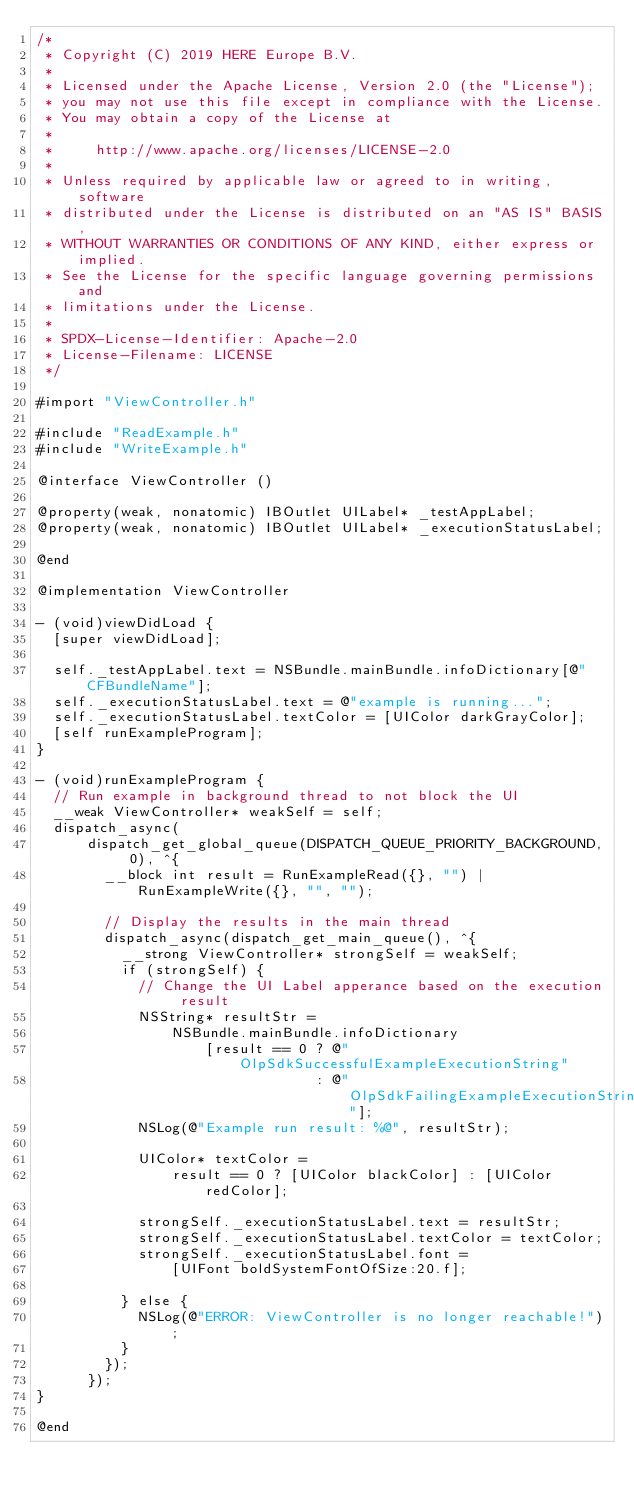Convert code to text. <code><loc_0><loc_0><loc_500><loc_500><_ObjectiveC_>/*
 * Copyright (C) 2019 HERE Europe B.V.
 *
 * Licensed under the Apache License, Version 2.0 (the "License");
 * you may not use this file except in compliance with the License.
 * You may obtain a copy of the License at
 *
 *     http://www.apache.org/licenses/LICENSE-2.0
 *
 * Unless required by applicable law or agreed to in writing, software
 * distributed under the License is distributed on an "AS IS" BASIS,
 * WITHOUT WARRANTIES OR CONDITIONS OF ANY KIND, either express or implied.
 * See the License for the specific language governing permissions and
 * limitations under the License.
 *
 * SPDX-License-Identifier: Apache-2.0
 * License-Filename: LICENSE
 */

#import "ViewController.h"

#include "ReadExample.h"
#include "WriteExample.h"

@interface ViewController ()

@property(weak, nonatomic) IBOutlet UILabel* _testAppLabel;
@property(weak, nonatomic) IBOutlet UILabel* _executionStatusLabel;

@end

@implementation ViewController

- (void)viewDidLoad {
  [super viewDidLoad];

  self._testAppLabel.text = NSBundle.mainBundle.infoDictionary[@"CFBundleName"];
  self._executionStatusLabel.text = @"example is running...";
  self._executionStatusLabel.textColor = [UIColor darkGrayColor];
  [self runExampleProgram];
}

- (void)runExampleProgram {
  // Run example in background thread to not block the UI
  __weak ViewController* weakSelf = self;
  dispatch_async(
      dispatch_get_global_queue(DISPATCH_QUEUE_PRIORITY_BACKGROUND, 0), ^{
        __block int result = RunExampleRead({}, "") | RunExampleWrite({}, "", "");

        // Display the results in the main thread
        dispatch_async(dispatch_get_main_queue(), ^{
          __strong ViewController* strongSelf = weakSelf;
          if (strongSelf) {
            // Change the UI Label apperance based on the execution result
            NSString* resultStr =
                NSBundle.mainBundle.infoDictionary
                    [result == 0 ? @"OlpSdkSuccessfulExampleExecutionString"
                                 : @"OlpSdkFailingExampleExecutionString"];
            NSLog(@"Example run result: %@", resultStr);

            UIColor* textColor =
                result == 0 ? [UIColor blackColor] : [UIColor redColor];

            strongSelf._executionStatusLabel.text = resultStr;
            strongSelf._executionStatusLabel.textColor = textColor;
            strongSelf._executionStatusLabel.font =
                [UIFont boldSystemFontOfSize:20.f];

          } else {
            NSLog(@"ERROR: ViewController is no longer reachable!");
          }
        });
      });
}

@end
</code> 